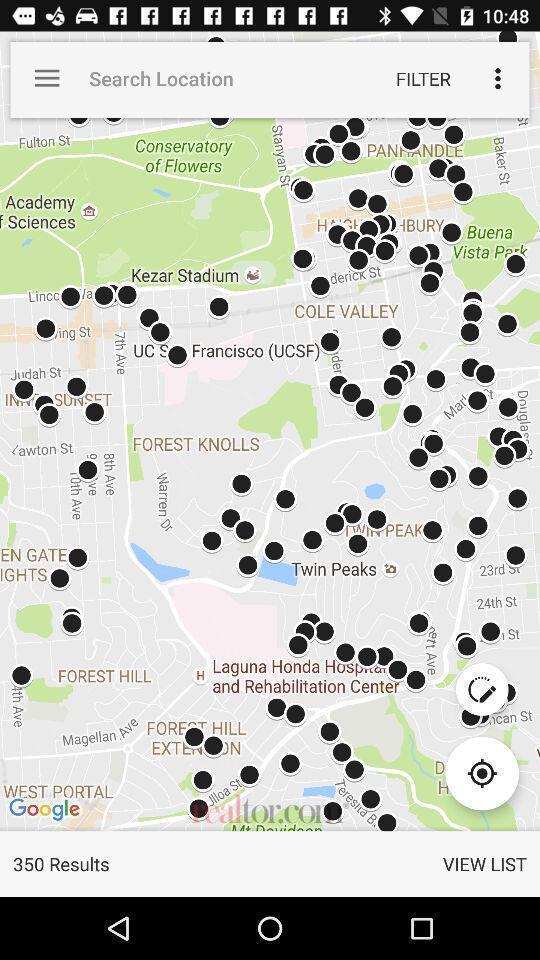Tell me what you see in this picture. Search result page showing map view. 